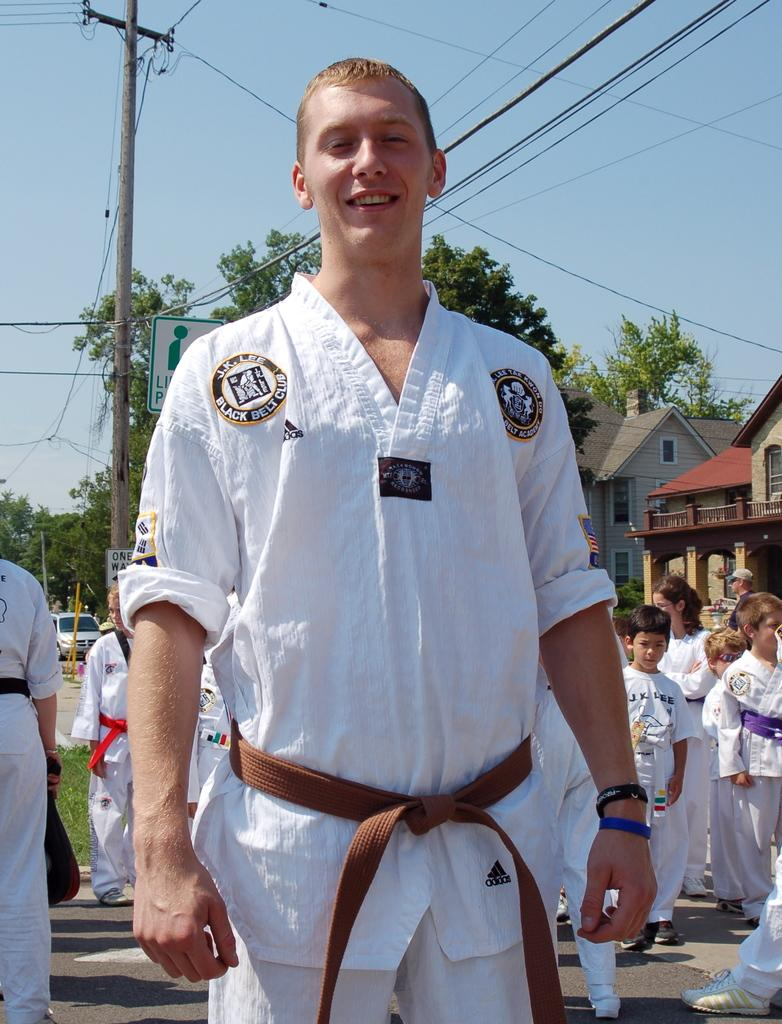What is the main subject in the image? There is a person standing in the image. What can be seen in the background of the image? There are trees, electrical poles, houses, and a car in the image. Are there any other people present in the image? Yes, there are people in the image. Can you tell me how many basketballs are visible in the image? There are no basketballs present in the image. What type of bushes can be seen growing near the houses in the image? There is no mention of bushes in the image; only trees, electrical poles, houses, and a car are visible. 